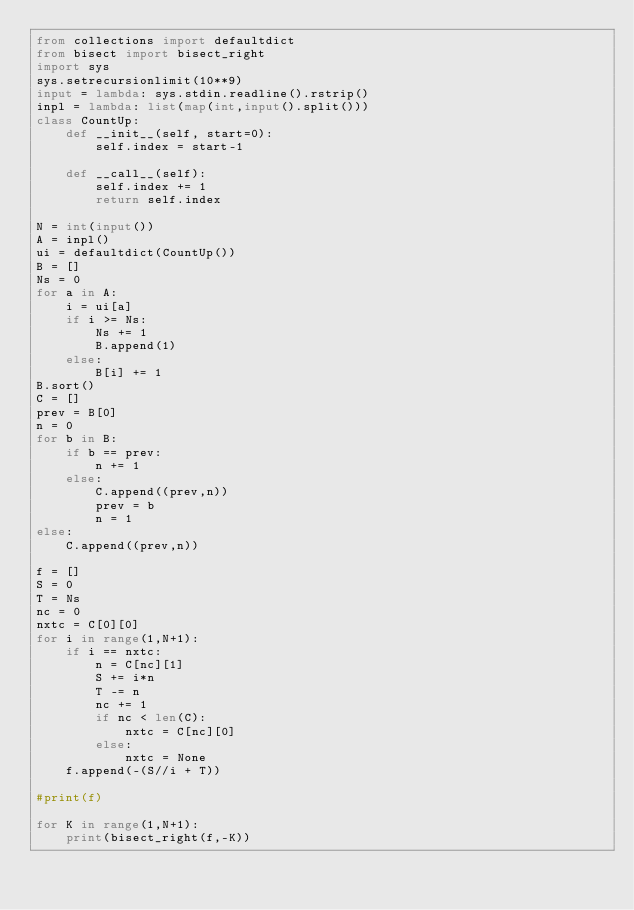<code> <loc_0><loc_0><loc_500><loc_500><_Python_>from collections import defaultdict
from bisect import bisect_right
import sys
sys.setrecursionlimit(10**9)
input = lambda: sys.stdin.readline().rstrip()
inpl = lambda: list(map(int,input().split()))
class CountUp:
    def __init__(self, start=0):
        self.index = start-1

    def __call__(self):
        self.index += 1
        return self.index

N = int(input())
A = inpl()
ui = defaultdict(CountUp())
B = []
Ns = 0
for a in A:
    i = ui[a]
    if i >= Ns:
        Ns += 1
        B.append(1)
    else:
        B[i] += 1
B.sort()
C = []
prev = B[0]
n = 0
for b in B:
    if b == prev:
        n += 1
    else:
        C.append((prev,n))
        prev = b
        n = 1
else:
    C.append((prev,n))

f = []
S = 0
T = Ns
nc = 0
nxtc = C[0][0]
for i in range(1,N+1):
    if i == nxtc:
        n = C[nc][1]
        S += i*n
        T -= n
        nc += 1
        if nc < len(C):
            nxtc = C[nc][0]
        else:
            nxtc = None
    f.append(-(S//i + T))

#print(f)

for K in range(1,N+1):
    print(bisect_right(f,-K))</code> 